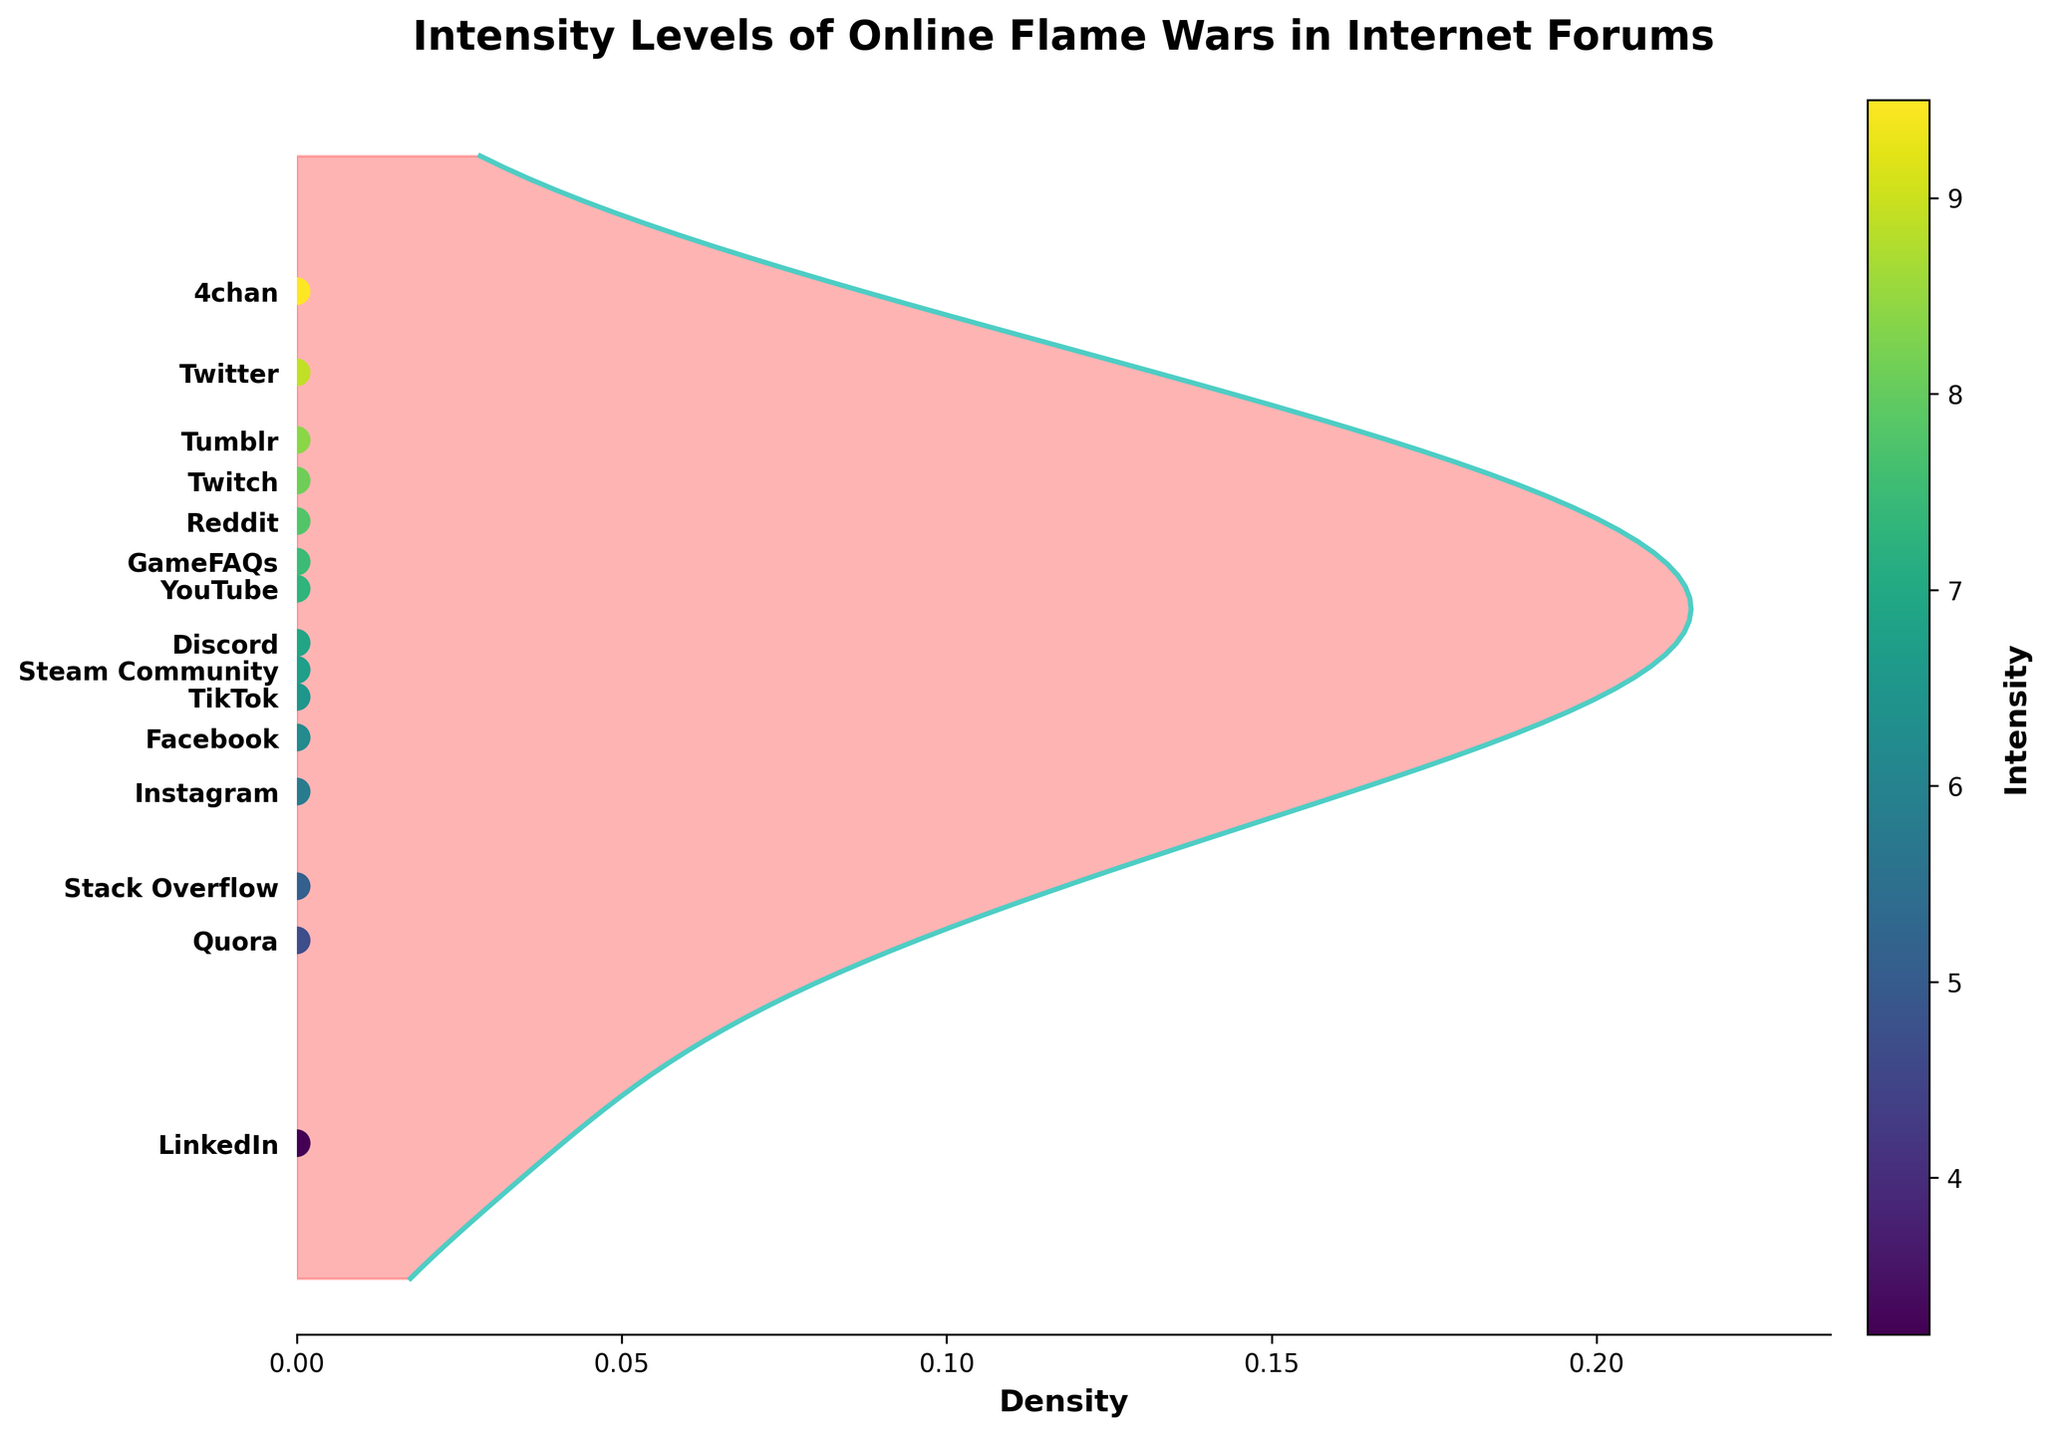what is the title of the plot? The title is usually found at the top of the figure. It describes what the plot is about.
Answer: Intensity Levels of Online Flame Wars in Internet Forums Which forum has the highest intensity level? By looking at the positions of the scatter points along the intensity axis, the forum with the highest position will have the highest intensity level.
Answer: 4chan How many forums are displayed in the plot? Each scatter point represents a forum, and we count the number of scatter points in the figure.
Answer: 15 What's the range of intensity levels shown in the plot? The range is determined by the minimum and maximum values on the intensity axis.
Answer: 3.2 to 9.5 Which forum has a lower intensity level, Facebook or Discord? By comparing the positions of the scatter points for Facebook and Discord along the intensity axis, you can see which is lower.
Answer: Facebook Is the intensity level of Tumblr higher than Twitch? By comparing the positions of the scatter points for Tumblr and Twitch along the intensity axis, you can determine if Tumblr is higher.
Answer: Yes What's the density like around an intensity level of 8.1? Density is reflected by the filled area, and this can be seen at the point where the intensity level is 8.1—how much area it covers vertically.
Answer: Medium density What is the average intensity level of all forums? Sum all intensity values and divide by the number of forums. (7.8+9.5+8.9+6.2+7.3+8.1+6.9+7.5+6.7+8.4+5.8+6.5+3.2+4.7+5.1)/15.
Answer: 6.8 Which forum has an intensity closest to 7.0? Compare each intensity value to 7.0 and find the nearest one. Discord is 6.9, which is closest to 7.0.
Answer: Discord What's the difference in intensity between TikTok and Quora? Subtract the intensity of Quora from the intensity of TikTok. 6.5 - 4.7.
Answer: 1.8 